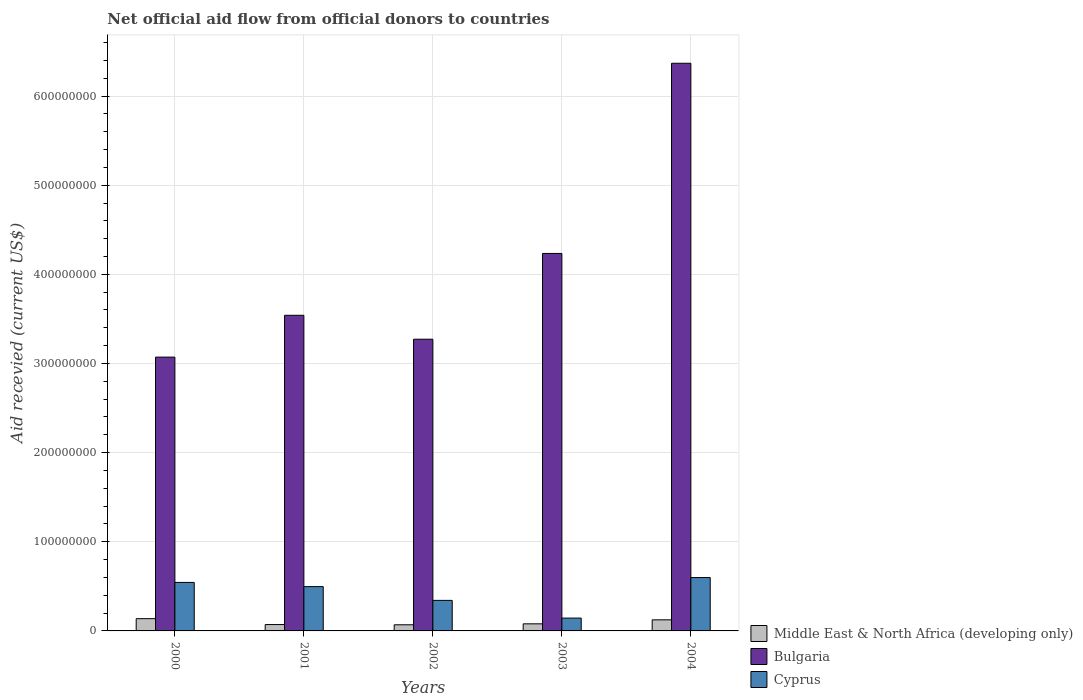How many bars are there on the 4th tick from the left?
Give a very brief answer. 3. How many bars are there on the 4th tick from the right?
Your answer should be compact. 3. What is the label of the 4th group of bars from the left?
Give a very brief answer. 2003. What is the total aid received in Bulgaria in 2000?
Your response must be concise. 3.07e+08. Across all years, what is the maximum total aid received in Middle East & North Africa (developing only)?
Your answer should be very brief. 1.38e+07. Across all years, what is the minimum total aid received in Cyprus?
Your answer should be very brief. 1.44e+07. In which year was the total aid received in Middle East & North Africa (developing only) maximum?
Offer a terse response. 2000. What is the total total aid received in Bulgaria in the graph?
Your response must be concise. 2.05e+09. What is the difference between the total aid received in Cyprus in 2001 and that in 2003?
Offer a terse response. 3.53e+07. What is the difference between the total aid received in Bulgaria in 2002 and the total aid received in Middle East & North Africa (developing only) in 2004?
Provide a succinct answer. 3.15e+08. What is the average total aid received in Bulgaria per year?
Offer a terse response. 4.10e+08. In the year 2003, what is the difference between the total aid received in Cyprus and total aid received in Bulgaria?
Offer a terse response. -4.09e+08. In how many years, is the total aid received in Cyprus greater than 440000000 US$?
Provide a short and direct response. 0. What is the ratio of the total aid received in Bulgaria in 2000 to that in 2004?
Make the answer very short. 0.48. Is the total aid received in Cyprus in 2003 less than that in 2004?
Your answer should be compact. Yes. Is the difference between the total aid received in Cyprus in 2002 and 2003 greater than the difference between the total aid received in Bulgaria in 2002 and 2003?
Your answer should be very brief. Yes. What is the difference between the highest and the second highest total aid received in Middle East & North Africa (developing only)?
Your answer should be very brief. 1.32e+06. What is the difference between the highest and the lowest total aid received in Bulgaria?
Provide a succinct answer. 3.30e+08. In how many years, is the total aid received in Middle East & North Africa (developing only) greater than the average total aid received in Middle East & North Africa (developing only) taken over all years?
Give a very brief answer. 2. What does the 2nd bar from the left in 2003 represents?
Provide a succinct answer. Bulgaria. What does the 1st bar from the right in 2003 represents?
Keep it short and to the point. Cyprus. Is it the case that in every year, the sum of the total aid received in Bulgaria and total aid received in Cyprus is greater than the total aid received in Middle East & North Africa (developing only)?
Ensure brevity in your answer.  Yes. How many years are there in the graph?
Make the answer very short. 5. What is the difference between two consecutive major ticks on the Y-axis?
Your answer should be very brief. 1.00e+08. Are the values on the major ticks of Y-axis written in scientific E-notation?
Your response must be concise. No. What is the title of the graph?
Make the answer very short. Net official aid flow from official donors to countries. What is the label or title of the X-axis?
Your response must be concise. Years. What is the label or title of the Y-axis?
Give a very brief answer. Aid recevied (current US$). What is the Aid recevied (current US$) of Middle East & North Africa (developing only) in 2000?
Your response must be concise. 1.38e+07. What is the Aid recevied (current US$) in Bulgaria in 2000?
Provide a succinct answer. 3.07e+08. What is the Aid recevied (current US$) of Cyprus in 2000?
Provide a succinct answer. 5.44e+07. What is the Aid recevied (current US$) in Middle East & North Africa (developing only) in 2001?
Ensure brevity in your answer.  7.14e+06. What is the Aid recevied (current US$) in Bulgaria in 2001?
Offer a terse response. 3.54e+08. What is the Aid recevied (current US$) of Cyprus in 2001?
Offer a terse response. 4.97e+07. What is the Aid recevied (current US$) of Middle East & North Africa (developing only) in 2002?
Give a very brief answer. 6.88e+06. What is the Aid recevied (current US$) in Bulgaria in 2002?
Provide a succinct answer. 3.27e+08. What is the Aid recevied (current US$) of Cyprus in 2002?
Ensure brevity in your answer.  3.42e+07. What is the Aid recevied (current US$) in Middle East & North Africa (developing only) in 2003?
Your answer should be very brief. 7.95e+06. What is the Aid recevied (current US$) in Bulgaria in 2003?
Give a very brief answer. 4.23e+08. What is the Aid recevied (current US$) of Cyprus in 2003?
Ensure brevity in your answer.  1.44e+07. What is the Aid recevied (current US$) of Middle East & North Africa (developing only) in 2004?
Your answer should be very brief. 1.24e+07. What is the Aid recevied (current US$) of Bulgaria in 2004?
Keep it short and to the point. 6.37e+08. What is the Aid recevied (current US$) of Cyprus in 2004?
Offer a very short reply. 5.99e+07. Across all years, what is the maximum Aid recevied (current US$) of Middle East & North Africa (developing only)?
Give a very brief answer. 1.38e+07. Across all years, what is the maximum Aid recevied (current US$) in Bulgaria?
Provide a short and direct response. 6.37e+08. Across all years, what is the maximum Aid recevied (current US$) of Cyprus?
Offer a very short reply. 5.99e+07. Across all years, what is the minimum Aid recevied (current US$) in Middle East & North Africa (developing only)?
Your response must be concise. 6.88e+06. Across all years, what is the minimum Aid recevied (current US$) of Bulgaria?
Give a very brief answer. 3.07e+08. Across all years, what is the minimum Aid recevied (current US$) in Cyprus?
Keep it short and to the point. 1.44e+07. What is the total Aid recevied (current US$) in Middle East & North Africa (developing only) in the graph?
Make the answer very short. 4.82e+07. What is the total Aid recevied (current US$) in Bulgaria in the graph?
Make the answer very short. 2.05e+09. What is the total Aid recevied (current US$) of Cyprus in the graph?
Make the answer very short. 2.13e+08. What is the difference between the Aid recevied (current US$) of Middle East & North Africa (developing only) in 2000 and that in 2001?
Provide a short and direct response. 6.61e+06. What is the difference between the Aid recevied (current US$) of Bulgaria in 2000 and that in 2001?
Your answer should be compact. -4.69e+07. What is the difference between the Aid recevied (current US$) of Cyprus in 2000 and that in 2001?
Your response must be concise. 4.70e+06. What is the difference between the Aid recevied (current US$) in Middle East & North Africa (developing only) in 2000 and that in 2002?
Your answer should be compact. 6.87e+06. What is the difference between the Aid recevied (current US$) in Bulgaria in 2000 and that in 2002?
Offer a very short reply. -2.01e+07. What is the difference between the Aid recevied (current US$) of Cyprus in 2000 and that in 2002?
Ensure brevity in your answer.  2.02e+07. What is the difference between the Aid recevied (current US$) of Middle East & North Africa (developing only) in 2000 and that in 2003?
Offer a very short reply. 5.80e+06. What is the difference between the Aid recevied (current US$) in Bulgaria in 2000 and that in 2003?
Offer a very short reply. -1.16e+08. What is the difference between the Aid recevied (current US$) in Cyprus in 2000 and that in 2003?
Keep it short and to the point. 4.00e+07. What is the difference between the Aid recevied (current US$) of Middle East & North Africa (developing only) in 2000 and that in 2004?
Your response must be concise. 1.32e+06. What is the difference between the Aid recevied (current US$) of Bulgaria in 2000 and that in 2004?
Offer a terse response. -3.30e+08. What is the difference between the Aid recevied (current US$) in Cyprus in 2000 and that in 2004?
Give a very brief answer. -5.46e+06. What is the difference between the Aid recevied (current US$) of Middle East & North Africa (developing only) in 2001 and that in 2002?
Give a very brief answer. 2.60e+05. What is the difference between the Aid recevied (current US$) in Bulgaria in 2001 and that in 2002?
Offer a terse response. 2.68e+07. What is the difference between the Aid recevied (current US$) in Cyprus in 2001 and that in 2002?
Give a very brief answer. 1.54e+07. What is the difference between the Aid recevied (current US$) in Middle East & North Africa (developing only) in 2001 and that in 2003?
Your response must be concise. -8.10e+05. What is the difference between the Aid recevied (current US$) of Bulgaria in 2001 and that in 2003?
Give a very brief answer. -6.94e+07. What is the difference between the Aid recevied (current US$) in Cyprus in 2001 and that in 2003?
Offer a very short reply. 3.53e+07. What is the difference between the Aid recevied (current US$) in Middle East & North Africa (developing only) in 2001 and that in 2004?
Provide a succinct answer. -5.29e+06. What is the difference between the Aid recevied (current US$) in Bulgaria in 2001 and that in 2004?
Keep it short and to the point. -2.83e+08. What is the difference between the Aid recevied (current US$) in Cyprus in 2001 and that in 2004?
Your answer should be very brief. -1.02e+07. What is the difference between the Aid recevied (current US$) in Middle East & North Africa (developing only) in 2002 and that in 2003?
Give a very brief answer. -1.07e+06. What is the difference between the Aid recevied (current US$) of Bulgaria in 2002 and that in 2003?
Offer a terse response. -9.62e+07. What is the difference between the Aid recevied (current US$) of Cyprus in 2002 and that in 2003?
Your response must be concise. 1.99e+07. What is the difference between the Aid recevied (current US$) in Middle East & North Africa (developing only) in 2002 and that in 2004?
Provide a short and direct response. -5.55e+06. What is the difference between the Aid recevied (current US$) in Bulgaria in 2002 and that in 2004?
Make the answer very short. -3.10e+08. What is the difference between the Aid recevied (current US$) in Cyprus in 2002 and that in 2004?
Offer a very short reply. -2.56e+07. What is the difference between the Aid recevied (current US$) of Middle East & North Africa (developing only) in 2003 and that in 2004?
Offer a very short reply. -4.48e+06. What is the difference between the Aid recevied (current US$) in Bulgaria in 2003 and that in 2004?
Your answer should be compact. -2.13e+08. What is the difference between the Aid recevied (current US$) of Cyprus in 2003 and that in 2004?
Make the answer very short. -4.55e+07. What is the difference between the Aid recevied (current US$) in Middle East & North Africa (developing only) in 2000 and the Aid recevied (current US$) in Bulgaria in 2001?
Provide a short and direct response. -3.40e+08. What is the difference between the Aid recevied (current US$) of Middle East & North Africa (developing only) in 2000 and the Aid recevied (current US$) of Cyprus in 2001?
Provide a short and direct response. -3.60e+07. What is the difference between the Aid recevied (current US$) of Bulgaria in 2000 and the Aid recevied (current US$) of Cyprus in 2001?
Keep it short and to the point. 2.57e+08. What is the difference between the Aid recevied (current US$) of Middle East & North Africa (developing only) in 2000 and the Aid recevied (current US$) of Bulgaria in 2002?
Provide a succinct answer. -3.13e+08. What is the difference between the Aid recevied (current US$) of Middle East & North Africa (developing only) in 2000 and the Aid recevied (current US$) of Cyprus in 2002?
Your answer should be very brief. -2.05e+07. What is the difference between the Aid recevied (current US$) in Bulgaria in 2000 and the Aid recevied (current US$) in Cyprus in 2002?
Provide a short and direct response. 2.73e+08. What is the difference between the Aid recevied (current US$) of Middle East & North Africa (developing only) in 2000 and the Aid recevied (current US$) of Bulgaria in 2003?
Provide a short and direct response. -4.10e+08. What is the difference between the Aid recevied (current US$) of Middle East & North Africa (developing only) in 2000 and the Aid recevied (current US$) of Cyprus in 2003?
Offer a terse response. -6.40e+05. What is the difference between the Aid recevied (current US$) in Bulgaria in 2000 and the Aid recevied (current US$) in Cyprus in 2003?
Ensure brevity in your answer.  2.93e+08. What is the difference between the Aid recevied (current US$) of Middle East & North Africa (developing only) in 2000 and the Aid recevied (current US$) of Bulgaria in 2004?
Your response must be concise. -6.23e+08. What is the difference between the Aid recevied (current US$) of Middle East & North Africa (developing only) in 2000 and the Aid recevied (current US$) of Cyprus in 2004?
Offer a terse response. -4.61e+07. What is the difference between the Aid recevied (current US$) in Bulgaria in 2000 and the Aid recevied (current US$) in Cyprus in 2004?
Your answer should be very brief. 2.47e+08. What is the difference between the Aid recevied (current US$) of Middle East & North Africa (developing only) in 2001 and the Aid recevied (current US$) of Bulgaria in 2002?
Make the answer very short. -3.20e+08. What is the difference between the Aid recevied (current US$) in Middle East & North Africa (developing only) in 2001 and the Aid recevied (current US$) in Cyprus in 2002?
Ensure brevity in your answer.  -2.71e+07. What is the difference between the Aid recevied (current US$) in Bulgaria in 2001 and the Aid recevied (current US$) in Cyprus in 2002?
Offer a very short reply. 3.20e+08. What is the difference between the Aid recevied (current US$) of Middle East & North Africa (developing only) in 2001 and the Aid recevied (current US$) of Bulgaria in 2003?
Offer a very short reply. -4.16e+08. What is the difference between the Aid recevied (current US$) in Middle East & North Africa (developing only) in 2001 and the Aid recevied (current US$) in Cyprus in 2003?
Your answer should be very brief. -7.25e+06. What is the difference between the Aid recevied (current US$) of Bulgaria in 2001 and the Aid recevied (current US$) of Cyprus in 2003?
Keep it short and to the point. 3.40e+08. What is the difference between the Aid recevied (current US$) of Middle East & North Africa (developing only) in 2001 and the Aid recevied (current US$) of Bulgaria in 2004?
Offer a terse response. -6.30e+08. What is the difference between the Aid recevied (current US$) in Middle East & North Africa (developing only) in 2001 and the Aid recevied (current US$) in Cyprus in 2004?
Keep it short and to the point. -5.27e+07. What is the difference between the Aid recevied (current US$) of Bulgaria in 2001 and the Aid recevied (current US$) of Cyprus in 2004?
Keep it short and to the point. 2.94e+08. What is the difference between the Aid recevied (current US$) of Middle East & North Africa (developing only) in 2002 and the Aid recevied (current US$) of Bulgaria in 2003?
Provide a succinct answer. -4.17e+08. What is the difference between the Aid recevied (current US$) in Middle East & North Africa (developing only) in 2002 and the Aid recevied (current US$) in Cyprus in 2003?
Provide a short and direct response. -7.51e+06. What is the difference between the Aid recevied (current US$) of Bulgaria in 2002 and the Aid recevied (current US$) of Cyprus in 2003?
Provide a short and direct response. 3.13e+08. What is the difference between the Aid recevied (current US$) of Middle East & North Africa (developing only) in 2002 and the Aid recevied (current US$) of Bulgaria in 2004?
Provide a succinct answer. -6.30e+08. What is the difference between the Aid recevied (current US$) of Middle East & North Africa (developing only) in 2002 and the Aid recevied (current US$) of Cyprus in 2004?
Ensure brevity in your answer.  -5.30e+07. What is the difference between the Aid recevied (current US$) of Bulgaria in 2002 and the Aid recevied (current US$) of Cyprus in 2004?
Make the answer very short. 2.67e+08. What is the difference between the Aid recevied (current US$) of Middle East & North Africa (developing only) in 2003 and the Aid recevied (current US$) of Bulgaria in 2004?
Your answer should be very brief. -6.29e+08. What is the difference between the Aid recevied (current US$) in Middle East & North Africa (developing only) in 2003 and the Aid recevied (current US$) in Cyprus in 2004?
Provide a short and direct response. -5.19e+07. What is the difference between the Aid recevied (current US$) of Bulgaria in 2003 and the Aid recevied (current US$) of Cyprus in 2004?
Ensure brevity in your answer.  3.64e+08. What is the average Aid recevied (current US$) of Middle East & North Africa (developing only) per year?
Offer a very short reply. 9.63e+06. What is the average Aid recevied (current US$) in Bulgaria per year?
Ensure brevity in your answer.  4.10e+08. What is the average Aid recevied (current US$) of Cyprus per year?
Provide a short and direct response. 4.25e+07. In the year 2000, what is the difference between the Aid recevied (current US$) of Middle East & North Africa (developing only) and Aid recevied (current US$) of Bulgaria?
Your answer should be compact. -2.93e+08. In the year 2000, what is the difference between the Aid recevied (current US$) of Middle East & North Africa (developing only) and Aid recevied (current US$) of Cyprus?
Your answer should be very brief. -4.06e+07. In the year 2000, what is the difference between the Aid recevied (current US$) of Bulgaria and Aid recevied (current US$) of Cyprus?
Keep it short and to the point. 2.53e+08. In the year 2001, what is the difference between the Aid recevied (current US$) in Middle East & North Africa (developing only) and Aid recevied (current US$) in Bulgaria?
Provide a short and direct response. -3.47e+08. In the year 2001, what is the difference between the Aid recevied (current US$) in Middle East & North Africa (developing only) and Aid recevied (current US$) in Cyprus?
Provide a succinct answer. -4.26e+07. In the year 2001, what is the difference between the Aid recevied (current US$) in Bulgaria and Aid recevied (current US$) in Cyprus?
Provide a succinct answer. 3.04e+08. In the year 2002, what is the difference between the Aid recevied (current US$) in Middle East & North Africa (developing only) and Aid recevied (current US$) in Bulgaria?
Make the answer very short. -3.20e+08. In the year 2002, what is the difference between the Aid recevied (current US$) of Middle East & North Africa (developing only) and Aid recevied (current US$) of Cyprus?
Provide a short and direct response. -2.74e+07. In the year 2002, what is the difference between the Aid recevied (current US$) in Bulgaria and Aid recevied (current US$) in Cyprus?
Provide a succinct answer. 2.93e+08. In the year 2003, what is the difference between the Aid recevied (current US$) in Middle East & North Africa (developing only) and Aid recevied (current US$) in Bulgaria?
Your response must be concise. -4.15e+08. In the year 2003, what is the difference between the Aid recevied (current US$) in Middle East & North Africa (developing only) and Aid recevied (current US$) in Cyprus?
Offer a very short reply. -6.44e+06. In the year 2003, what is the difference between the Aid recevied (current US$) in Bulgaria and Aid recevied (current US$) in Cyprus?
Offer a terse response. 4.09e+08. In the year 2004, what is the difference between the Aid recevied (current US$) of Middle East & North Africa (developing only) and Aid recevied (current US$) of Bulgaria?
Keep it short and to the point. -6.24e+08. In the year 2004, what is the difference between the Aid recevied (current US$) in Middle East & North Africa (developing only) and Aid recevied (current US$) in Cyprus?
Your answer should be compact. -4.74e+07. In the year 2004, what is the difference between the Aid recevied (current US$) of Bulgaria and Aid recevied (current US$) of Cyprus?
Your response must be concise. 5.77e+08. What is the ratio of the Aid recevied (current US$) of Middle East & North Africa (developing only) in 2000 to that in 2001?
Your response must be concise. 1.93. What is the ratio of the Aid recevied (current US$) of Bulgaria in 2000 to that in 2001?
Offer a terse response. 0.87. What is the ratio of the Aid recevied (current US$) of Cyprus in 2000 to that in 2001?
Provide a short and direct response. 1.09. What is the ratio of the Aid recevied (current US$) of Middle East & North Africa (developing only) in 2000 to that in 2002?
Give a very brief answer. 2. What is the ratio of the Aid recevied (current US$) in Bulgaria in 2000 to that in 2002?
Your response must be concise. 0.94. What is the ratio of the Aid recevied (current US$) in Cyprus in 2000 to that in 2002?
Offer a terse response. 1.59. What is the ratio of the Aid recevied (current US$) in Middle East & North Africa (developing only) in 2000 to that in 2003?
Give a very brief answer. 1.73. What is the ratio of the Aid recevied (current US$) of Bulgaria in 2000 to that in 2003?
Your answer should be compact. 0.73. What is the ratio of the Aid recevied (current US$) in Cyprus in 2000 to that in 2003?
Give a very brief answer. 3.78. What is the ratio of the Aid recevied (current US$) in Middle East & North Africa (developing only) in 2000 to that in 2004?
Provide a succinct answer. 1.11. What is the ratio of the Aid recevied (current US$) of Bulgaria in 2000 to that in 2004?
Give a very brief answer. 0.48. What is the ratio of the Aid recevied (current US$) of Cyprus in 2000 to that in 2004?
Provide a short and direct response. 0.91. What is the ratio of the Aid recevied (current US$) in Middle East & North Africa (developing only) in 2001 to that in 2002?
Your answer should be very brief. 1.04. What is the ratio of the Aid recevied (current US$) of Bulgaria in 2001 to that in 2002?
Offer a very short reply. 1.08. What is the ratio of the Aid recevied (current US$) in Cyprus in 2001 to that in 2002?
Give a very brief answer. 1.45. What is the ratio of the Aid recevied (current US$) of Middle East & North Africa (developing only) in 2001 to that in 2003?
Make the answer very short. 0.9. What is the ratio of the Aid recevied (current US$) of Bulgaria in 2001 to that in 2003?
Provide a short and direct response. 0.84. What is the ratio of the Aid recevied (current US$) in Cyprus in 2001 to that in 2003?
Provide a succinct answer. 3.45. What is the ratio of the Aid recevied (current US$) of Middle East & North Africa (developing only) in 2001 to that in 2004?
Make the answer very short. 0.57. What is the ratio of the Aid recevied (current US$) in Bulgaria in 2001 to that in 2004?
Provide a succinct answer. 0.56. What is the ratio of the Aid recevied (current US$) of Cyprus in 2001 to that in 2004?
Offer a very short reply. 0.83. What is the ratio of the Aid recevied (current US$) of Middle East & North Africa (developing only) in 2002 to that in 2003?
Provide a succinct answer. 0.87. What is the ratio of the Aid recevied (current US$) of Bulgaria in 2002 to that in 2003?
Keep it short and to the point. 0.77. What is the ratio of the Aid recevied (current US$) in Cyprus in 2002 to that in 2003?
Your answer should be compact. 2.38. What is the ratio of the Aid recevied (current US$) of Middle East & North Africa (developing only) in 2002 to that in 2004?
Your response must be concise. 0.55. What is the ratio of the Aid recevied (current US$) in Bulgaria in 2002 to that in 2004?
Provide a succinct answer. 0.51. What is the ratio of the Aid recevied (current US$) of Cyprus in 2002 to that in 2004?
Provide a succinct answer. 0.57. What is the ratio of the Aid recevied (current US$) of Middle East & North Africa (developing only) in 2003 to that in 2004?
Offer a very short reply. 0.64. What is the ratio of the Aid recevied (current US$) in Bulgaria in 2003 to that in 2004?
Provide a short and direct response. 0.67. What is the ratio of the Aid recevied (current US$) in Cyprus in 2003 to that in 2004?
Offer a very short reply. 0.24. What is the difference between the highest and the second highest Aid recevied (current US$) of Middle East & North Africa (developing only)?
Offer a terse response. 1.32e+06. What is the difference between the highest and the second highest Aid recevied (current US$) of Bulgaria?
Your answer should be very brief. 2.13e+08. What is the difference between the highest and the second highest Aid recevied (current US$) of Cyprus?
Your response must be concise. 5.46e+06. What is the difference between the highest and the lowest Aid recevied (current US$) of Middle East & North Africa (developing only)?
Offer a very short reply. 6.87e+06. What is the difference between the highest and the lowest Aid recevied (current US$) of Bulgaria?
Make the answer very short. 3.30e+08. What is the difference between the highest and the lowest Aid recevied (current US$) of Cyprus?
Keep it short and to the point. 4.55e+07. 